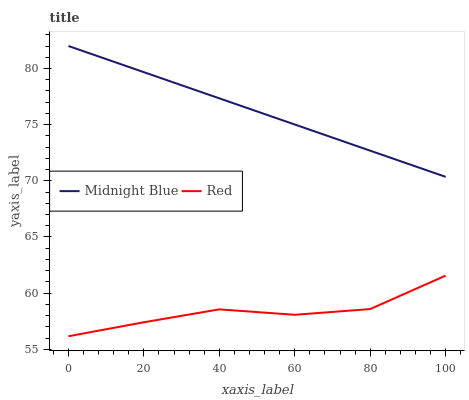Does Red have the minimum area under the curve?
Answer yes or no. Yes. Does Midnight Blue have the maximum area under the curve?
Answer yes or no. Yes. Does Red have the maximum area under the curve?
Answer yes or no. No. Is Midnight Blue the smoothest?
Answer yes or no. Yes. Is Red the roughest?
Answer yes or no. Yes. Is Red the smoothest?
Answer yes or no. No. Does Red have the lowest value?
Answer yes or no. Yes. Does Midnight Blue have the highest value?
Answer yes or no. Yes. Does Red have the highest value?
Answer yes or no. No. Is Red less than Midnight Blue?
Answer yes or no. Yes. Is Midnight Blue greater than Red?
Answer yes or no. Yes. Does Red intersect Midnight Blue?
Answer yes or no. No. 